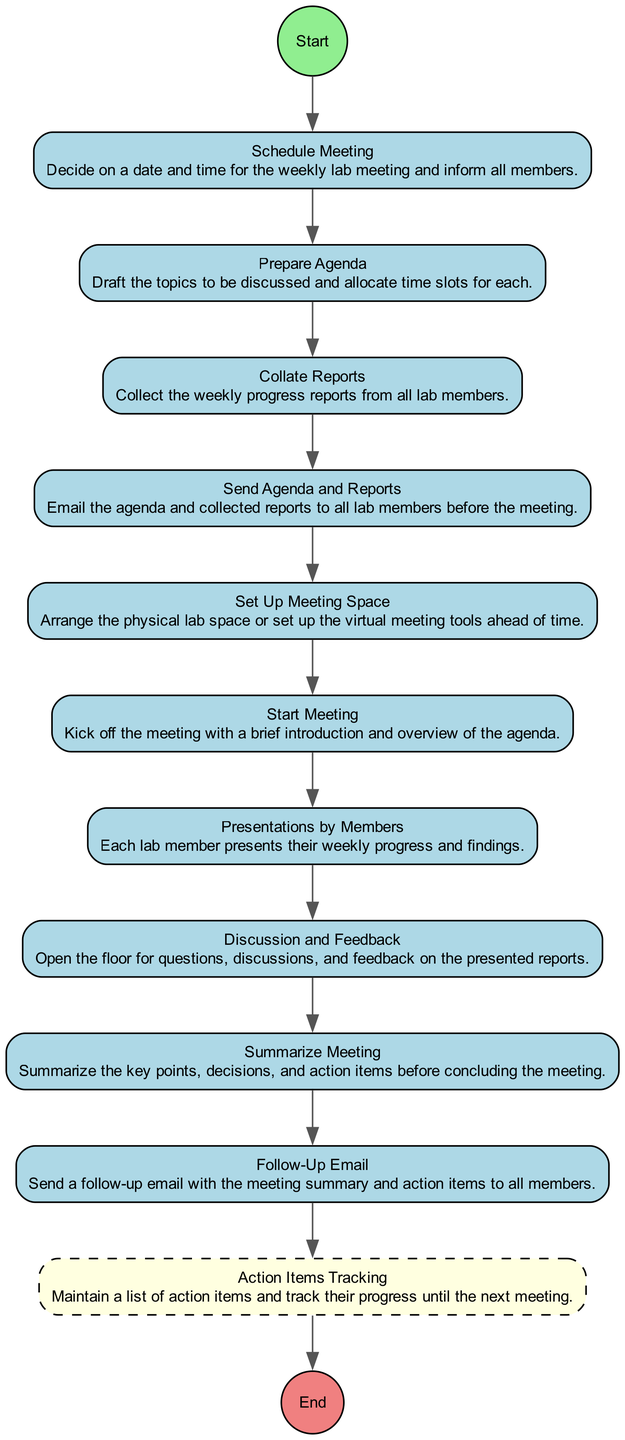What is the first action in the diagram? The diagram starts with the "Schedule Meeting" action, which is the first action to be performed in organizing a weekly lab meeting.
Answer: Schedule Meeting How many actions are there in the diagram? The diagram contains 10 actions listed sequentially from "Schedule Meeting" to "Follow-Up Email", so there are a total of 10 actions.
Answer: 10 What action directly follows "Prepare Agenda"? After "Prepare Agenda", the next action is "Collate Reports", as the order flows sequentially from agenda preparation to report collection.
Answer: Collate Reports What type is the last node in the diagram? The last node in the diagram is labeled "End" and is a circle shape, indicating it signifies the conclusion of the activity flow.
Answer: Circle Which action includes sending documents to members? "Send Agenda and Reports" is the action that involves emailing the agenda and reports to all lab members before the meeting, making it the task that includes sending documents.
Answer: Send Agenda and Reports How many edges connect the nodes in the diagram? There are 10 actions leading to the "End" node, resulting in a total of 10 edges connecting the actions in the flow.
Answer: 10 What is the primary purpose of the "Action Items Tracking"? "Action Items Tracking" serves the purpose of maintaining a list of action items and tracking their progress until the next meeting, ensuring follow-up on tasks assigned during the meeting.
Answer: Maintain a list of action items Which action occurs just before the "Start Meeting"? "Set Up Meeting Space" precedes the "Start Meeting", indicating that arrangements must be made prior to kicking off the meeting.
Answer: Set Up Meeting Space What is the fourth action in the sequence? The fourth action in the sequence is "Send Agenda and Reports", which occurs after drafting the agenda and collating reports, emphasizing communication prior to the meeting.
Answer: Send Agenda and Reports 